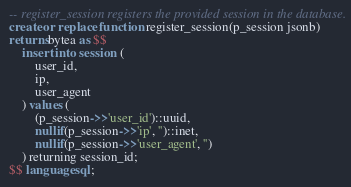Convert code to text. <code><loc_0><loc_0><loc_500><loc_500><_SQL_>-- register_session registers the provided session in the database.
create or replace function register_session(p_session jsonb)
returns bytea as $$
    insert into session (
        user_id,
        ip,
        user_agent
    ) values (
        (p_session->>'user_id')::uuid,
        nullif(p_session->>'ip', '')::inet,
        nullif(p_session->>'user_agent', '')
    ) returning session_id;
$$ language sql;
</code> 